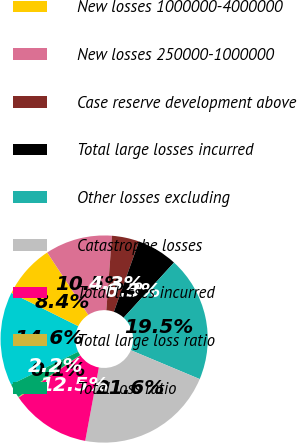<chart> <loc_0><loc_0><loc_500><loc_500><pie_chart><fcel>New losses greater than<fcel>New losses 1000000-4000000<fcel>New losses 250000-1000000<fcel>Case reserve development above<fcel>Total large losses incurred<fcel>Other losses excluding<fcel>Catastrophe losses<fcel>Total losses incurred<fcel>Total large loss ratio<fcel>Total loss ratio<nl><fcel>14.59%<fcel>8.39%<fcel>10.46%<fcel>4.26%<fcel>6.32%<fcel>19.54%<fcel>21.61%<fcel>12.52%<fcel>0.12%<fcel>2.19%<nl></chart> 